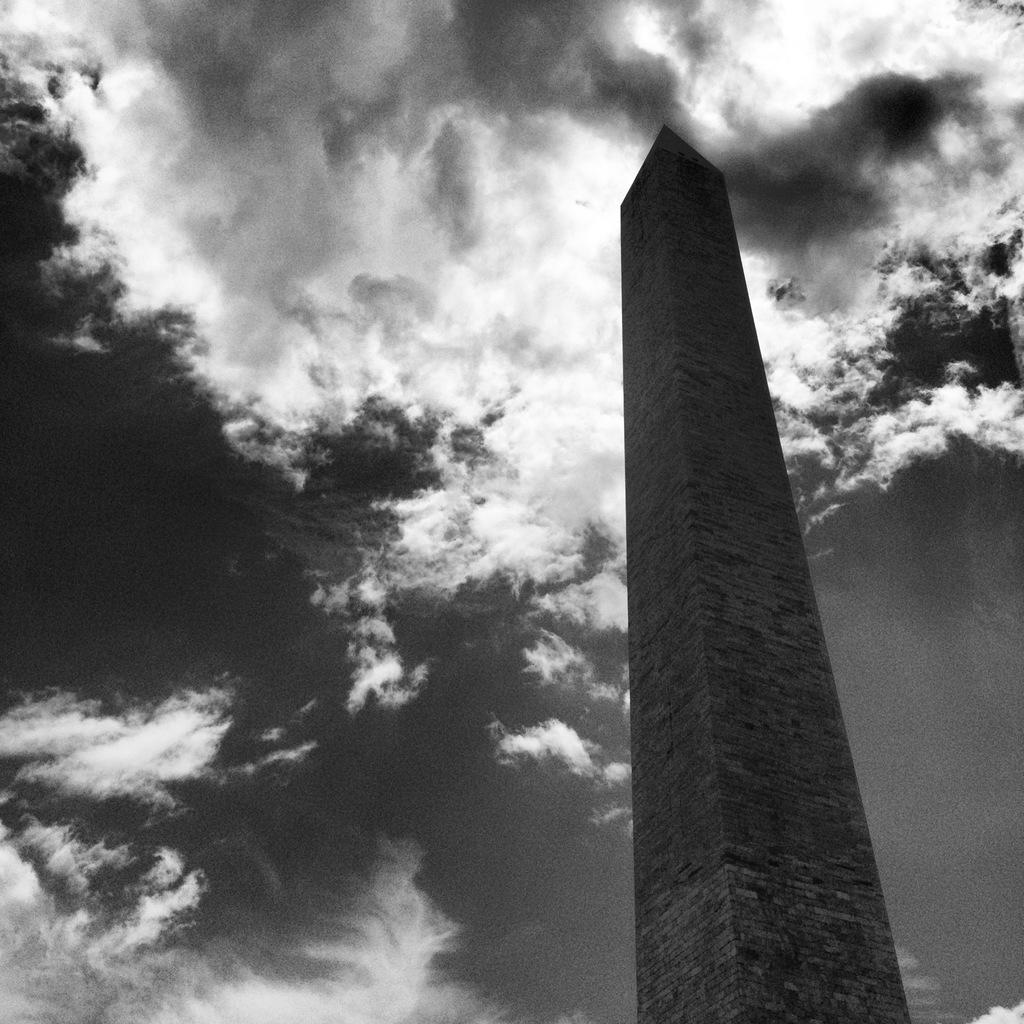What is the main subject in the image? There is a monument in the image. How would you describe the sky in the image? The sky is cloudy in the image. Can you see any signs of blood on the monument in the image? There is no blood present on the monument in the image. 